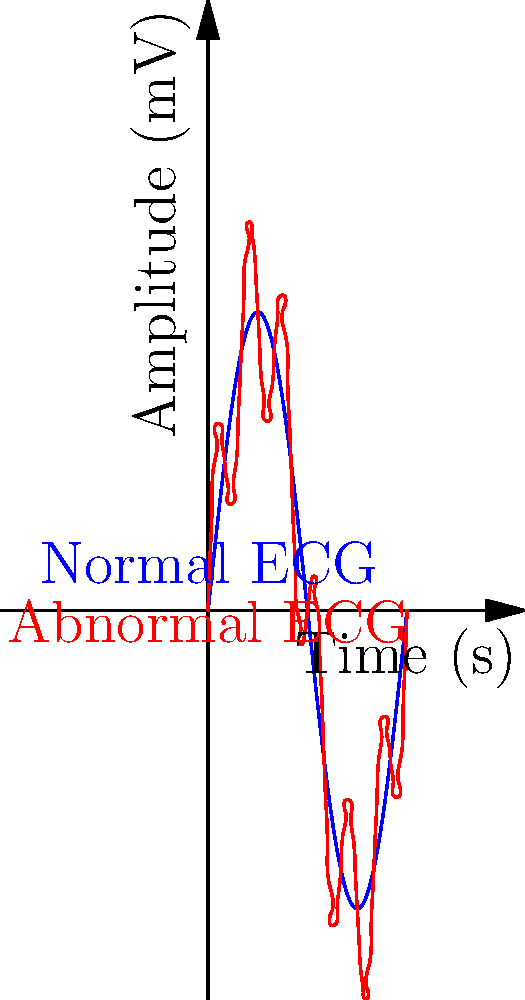Analyze the ECG waveforms shown in the graph. Which characteristic in the abnormal ECG (red) suggests a potential heart rhythm disorder? To analyze the ECG waveforms and identify potential heart rhythm disorders, follow these steps:

1. Observe the normal ECG (blue line):
   - It shows a smooth, regular sine wave pattern.
   - This represents a typical healthy heart rhythm.

2. Examine the abnormal ECG (red line):
   - It follows the general pattern of the normal ECG but with additional oscillations.
   - These extra oscillations are superimposed on the main waveform.

3. Compare the two waveforms:
   - The abnormal ECG has a higher frequency component added to the base rhythm.
   - This is evident from the small, rapid oscillations present throughout the waveform.

4. Interpret the abnormal pattern:
   - The presence of these rapid oscillations suggests an irregular electrical activity in the heart.
   - This pattern is consistent with atrial fibrillation, a common heart rhythm disorder.

5. Identify the key characteristic:
   - The most notable feature of the abnormal ECG is the presence of rapid, irregular oscillations.
   - These oscillations are not present in the normal ECG and indicate an underlying rhythm disturbance.

Therefore, the characteristic in the abnormal ECG that suggests a potential heart rhythm disorder is the presence of rapid, irregular oscillations superimposed on the main waveform.
Answer: Rapid, irregular oscillations 